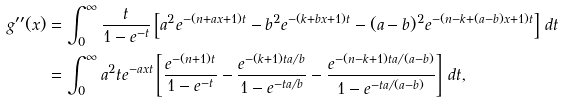Convert formula to latex. <formula><loc_0><loc_0><loc_500><loc_500>g ^ { \prime \prime } ( x ) & = \int _ { 0 } ^ { \infty } \frac { t } { 1 - e ^ { - t } } \left [ a ^ { 2 } e ^ { - ( n + a x + 1 ) t } - b ^ { 2 } e ^ { - ( k + b x + 1 ) t } - ( a - b ) ^ { 2 } e ^ { - ( n - k + ( a - b ) x + 1 ) t } \right ] \, d t \\ & = \int _ { 0 } ^ { \infty } a ^ { 2 } t e ^ { - a x t } \left [ \frac { e ^ { - ( n + 1 ) t } } { 1 - e ^ { - t } } - \frac { e ^ { - ( k + 1 ) t a / b } } { 1 - e ^ { - t a / b } } - \frac { e ^ { - ( n - k + 1 ) t a / ( a - b ) } } { 1 - e ^ { - t a / ( a - b ) } } \right ] \, d t ,</formula> 